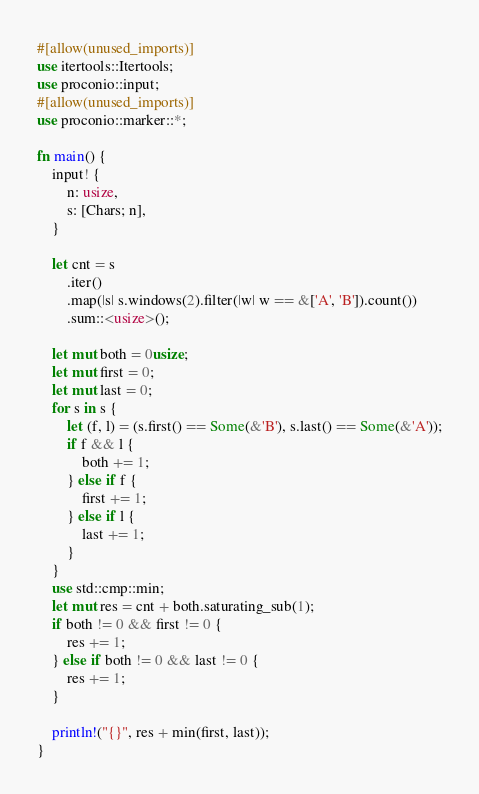Convert code to text. <code><loc_0><loc_0><loc_500><loc_500><_Rust_>#[allow(unused_imports)]
use itertools::Itertools;
use proconio::input;
#[allow(unused_imports)]
use proconio::marker::*;

fn main() {
    input! {
        n: usize,
        s: [Chars; n],
    }

    let cnt = s
        .iter()
        .map(|s| s.windows(2).filter(|w| w == &['A', 'B']).count())
        .sum::<usize>();

    let mut both = 0usize;
    let mut first = 0;
    let mut last = 0;
    for s in s {
        let (f, l) = (s.first() == Some(&'B'), s.last() == Some(&'A'));
        if f && l {
            both += 1;
        } else if f {
            first += 1;
        } else if l {
            last += 1;
        }
    }
    use std::cmp::min;
    let mut res = cnt + both.saturating_sub(1);
    if both != 0 && first != 0 {
        res += 1;
    } else if both != 0 && last != 0 {
        res += 1;
    }

    println!("{}", res + min(first, last));
}
</code> 